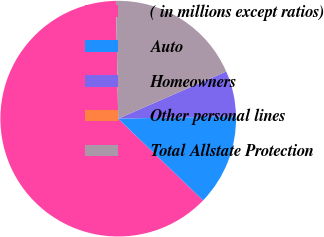Convert chart to OTSL. <chart><loc_0><loc_0><loc_500><loc_500><pie_chart><fcel>( in millions except ratios)<fcel>Auto<fcel>Homeowners<fcel>Other personal lines<fcel>Total Allstate Protection<nl><fcel>62.49%<fcel>12.5%<fcel>6.25%<fcel>0.0%<fcel>18.75%<nl></chart> 